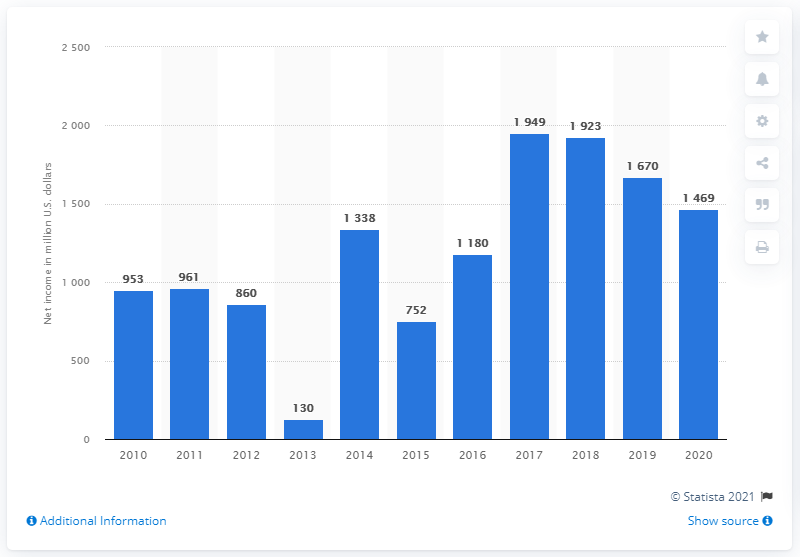Identify some key points in this picture. Waste Management Inc.'s net income in the previous year was $1,670 million. Since 2017, Waste Management Inc has experienced a decline in its net income. 